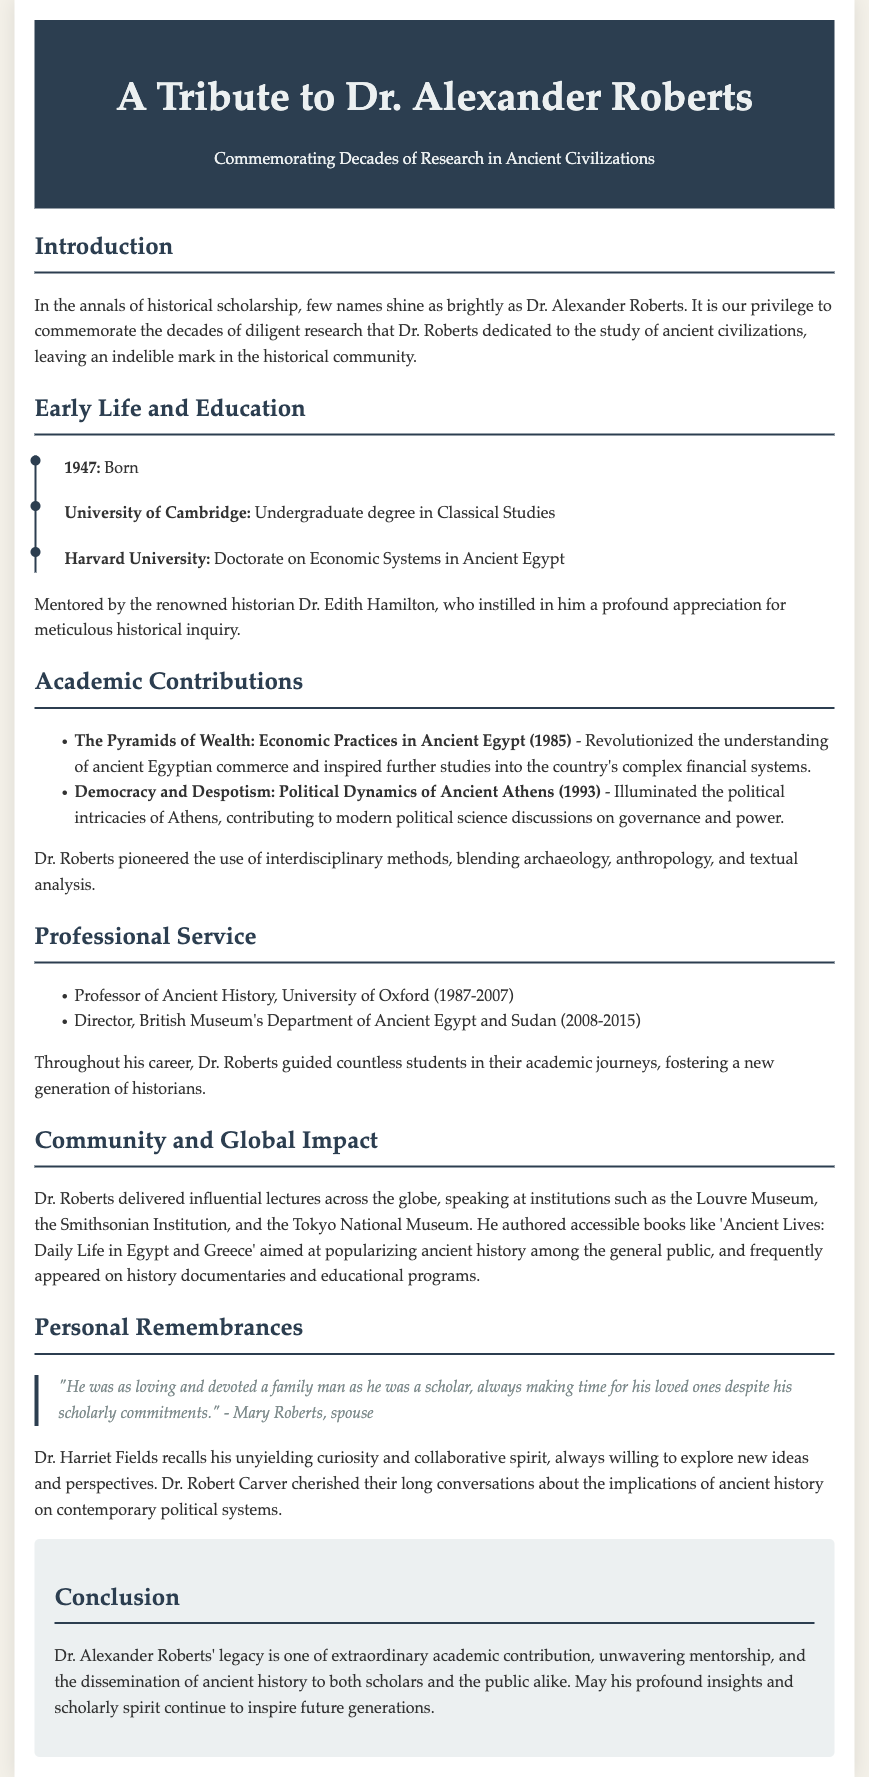What year was Dr. Alexander Roberts born? The document states that Dr. Alexander Roberts was born in 1947.
Answer: 1947 What is the title of Dr. Roberts' doctorate? He earned his doctorate on "Economic Systems in Ancient Egypt."
Answer: Economic Systems in Ancient Egypt Which university did Dr. Roberts work at as a professor? The document mentions that he was a Professor of Ancient History at the University of Oxford.
Answer: University of Oxford What was the focus of Dr. Roberts' book published in 1985? The book "The Pyramids of Wealth" focused on the economic practices in Ancient Egypt.
Answer: Economic practices in Ancient Egypt Who mentored Dr. Roberts during his education? Dr. Edith Hamilton is noted as his mentor, who influenced his approach to historical inquiry.
Answer: Dr. Edith Hamilton What is a key theme of Dr. Roberts' research as mentioned in the document? His research frequently blended archaeology, anthropology, and textual analysis.
Answer: Blending archaeology, anthropology, and textual analysis How long did Dr. Roberts serve as Director of the British Museum's Department of Ancient Egypt and Sudan? He served from 2008 to 2015, which is a span of 7 years.
Answer: 7 years What was Dr. Roberts' contribution to making history accessible to the public? He authored books aimed at popularizing ancient history, such as "Ancient Lives: Daily Life in Egypt and Greece."
Answer: Ancient Lives: Daily Life in Egypt and Greece What significant aspect of Dr. Roberts' character is highlighted in personal remembrances? He was described as a loving and devoted family man, illustrating his balanced personal and professional life.
Answer: Loving and devoted family man 